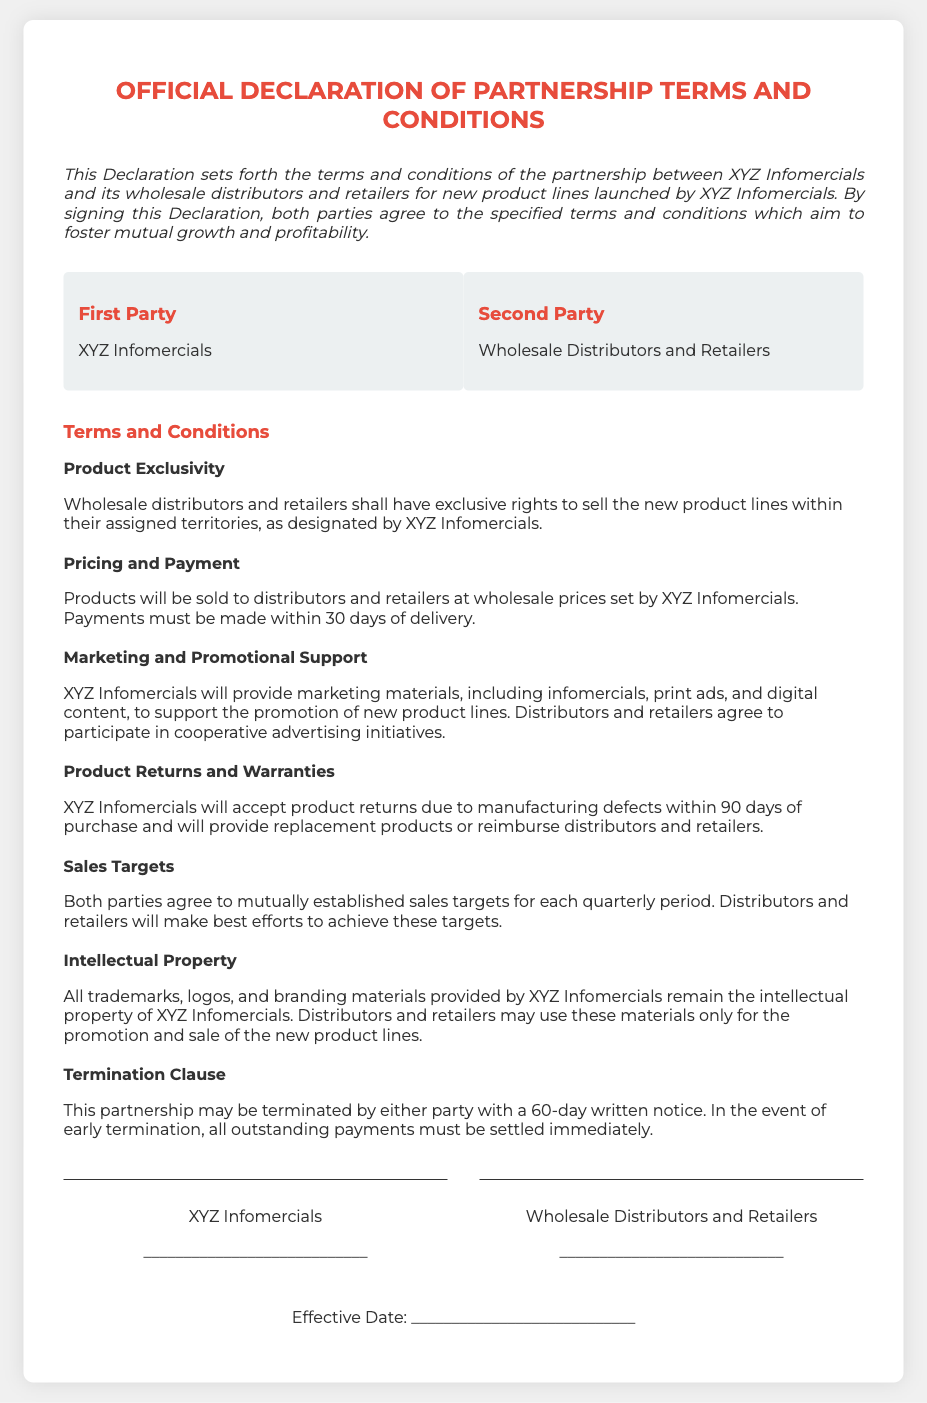What are the two parties involved? The two parties mentioned are XYZ Infomercials and Wholesale Distributors and Retailers.
Answer: XYZ Infomercials and Wholesale Distributors and Retailers What is the effective period for product returns? The document states that returns due to manufacturing defects are accepted within 90 days of purchase.
Answer: 90 days What must be done if either party wants to terminate the partnership? The document specifies that termination requires a 60-day written notice from either party.
Answer: 60-day written notice Who provides marketing materials? The document indicates that XYZ Infomercials will provide marketing materials for promotion.
Answer: XYZ Infomercials What type of rights do wholesale distributors and retailers receive? They are granted exclusive rights to sell new product lines in designated territories by XYZ Infomercials.
Answer: Exclusive rights What are distributors and retailers expected to achieve? The document mentions mutual sales targets that both parties agree upon for each quarterly period.
Answer: Sales targets What will happen to trademarks and logos? The document states that all trademarks, logos, and branding materials remain the intellectual property of XYZ Infomercials.
Answer: Intellectual property What happens in case of early termination? The partnership requires settling all outstanding payments immediately upon early termination.
Answer: Settle outstanding payments immediately 